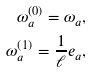<formula> <loc_0><loc_0><loc_500><loc_500>\omega _ { a } ^ { \left ( 0 \right ) } = \omega _ { a } , \\ \omega _ { a } ^ { \left ( 1 \right ) } = \frac { 1 } { \ell } e _ { a } ,</formula> 